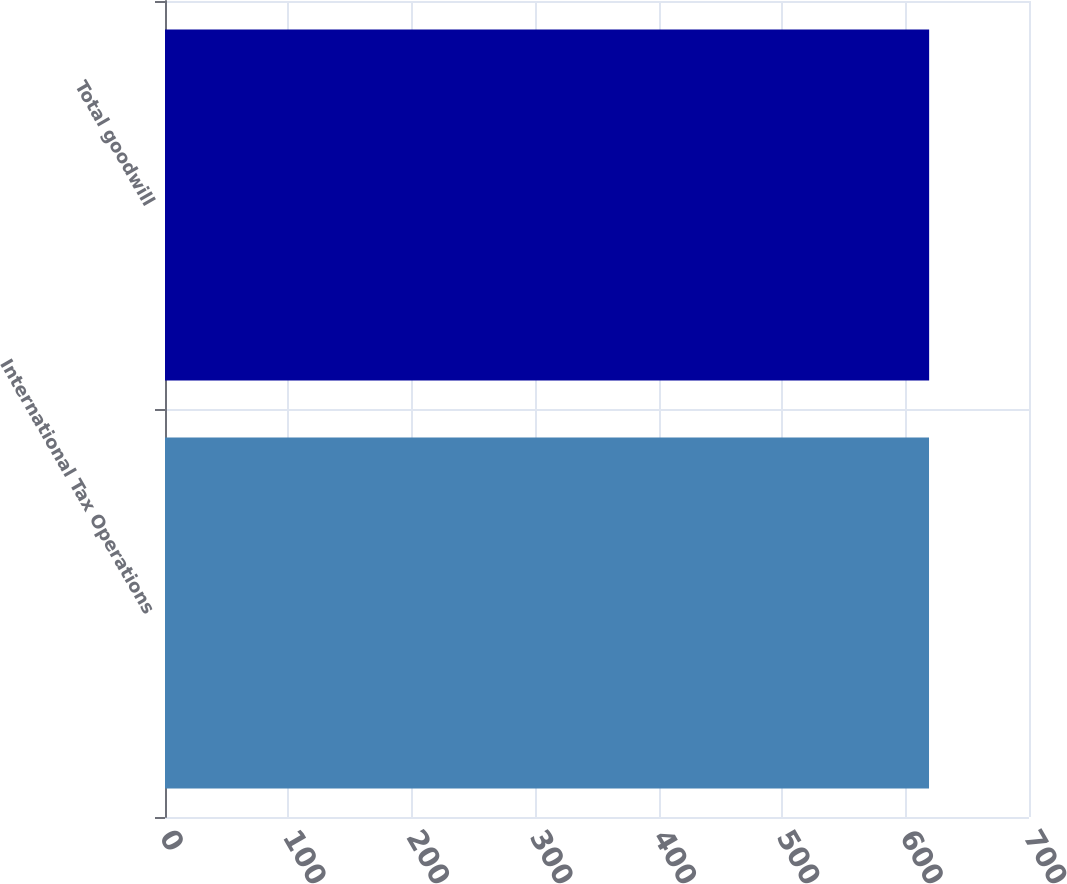<chart> <loc_0><loc_0><loc_500><loc_500><bar_chart><fcel>International Tax Operations<fcel>Total goodwill<nl><fcel>619<fcel>619.1<nl></chart> 